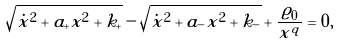Convert formula to latex. <formula><loc_0><loc_0><loc_500><loc_500>\sqrt { \dot { x } ^ { 2 } + a _ { + } x ^ { 2 } + k _ { + } } - \sqrt { \dot { x } ^ { 2 } + a _ { - } x ^ { 2 } + k _ { - } } + \frac { \varrho _ { 0 } } { x ^ { q } } = 0 ,</formula> 